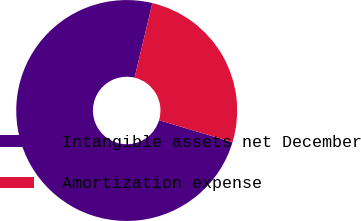<chart> <loc_0><loc_0><loc_500><loc_500><pie_chart><fcel>Intangible assets net December<fcel>Amortization expense<nl><fcel>74.11%<fcel>25.89%<nl></chart> 